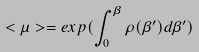Convert formula to latex. <formula><loc_0><loc_0><loc_500><loc_500>< \mu > = e x p ( \int _ { 0 } ^ { \beta } \rho ( \beta ^ { \prime } ) d \beta ^ { \prime } )</formula> 